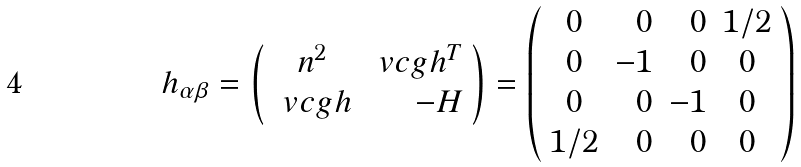<formula> <loc_0><loc_0><loc_500><loc_500>h _ { \alpha \beta } = \left ( \begin{array} { c r } n ^ { 2 } & \ v c g { h } ^ { T } \\ \ v c g { h } & - H \end{array} \right ) = \left ( \begin{array} { c r r c } 0 & 0 & 0 & 1 / 2 \\ 0 & - 1 & 0 & 0 \\ 0 & 0 & - 1 & 0 \\ 1 / 2 & 0 & 0 & 0 \end{array} \right )</formula> 